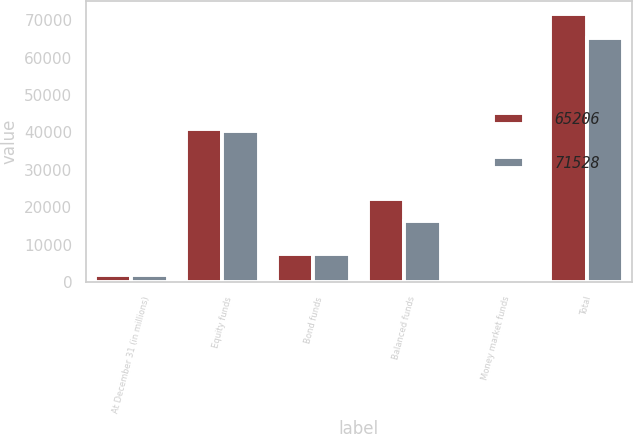<chart> <loc_0><loc_0><loc_500><loc_500><stacked_bar_chart><ecel><fcel>At December 31 (in millions)<fcel>Equity funds<fcel>Bond funds<fcel>Balanced funds<fcel>Money market funds<fcel>Total<nl><fcel>65206<fcel>2014<fcel>40811<fcel>7566<fcel>22354<fcel>797<fcel>71528<nl><fcel>71528<fcel>2013<fcel>40497<fcel>7458<fcel>16384<fcel>867<fcel>65206<nl></chart> 